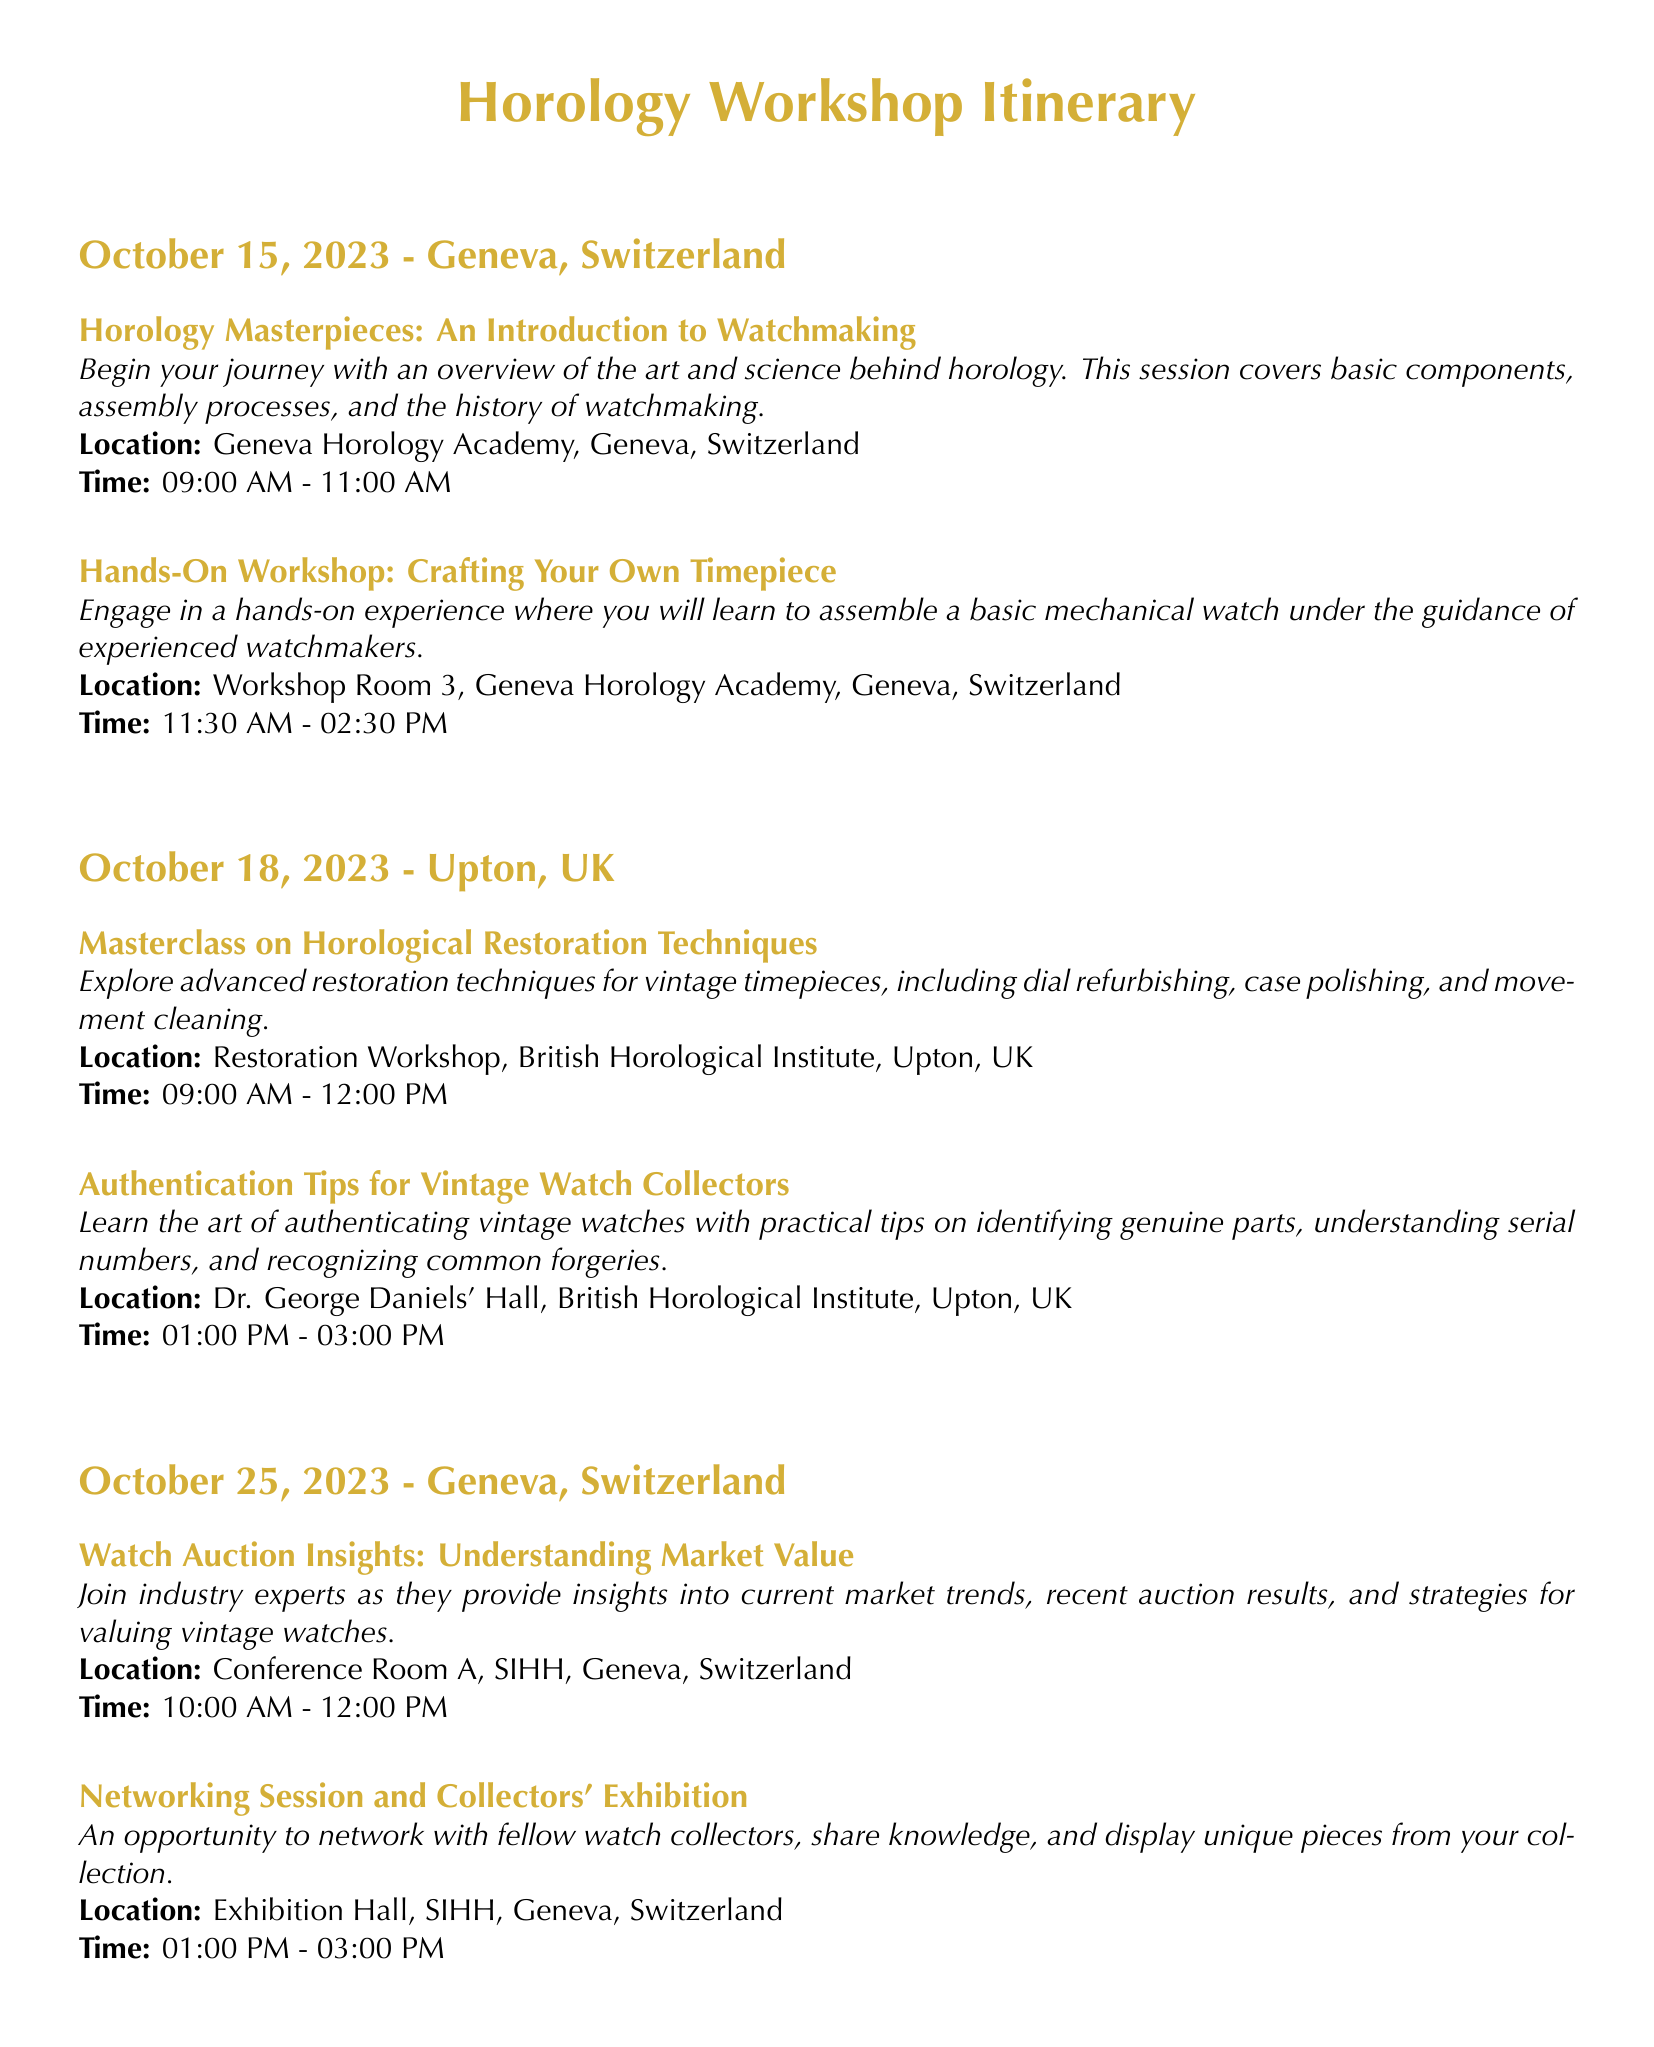What is the first workshop on the itinerary? The first workshop listed is "Horology Masterpieces: An Introduction to Watchmaking".
Answer: Horology Masterpieces: An Introduction to Watchmaking What is the location of the "Hands-On Workshop: Crafting Your Own Timepiece"? The workshop will take place in Workshop Room 3, Geneva Horology Academy, Geneva, Switzerland.
Answer: Workshop Room 3, Geneva Horology Academy, Geneva, Switzerland How long does the "Masterclass on Horological Restoration Techniques" last? The masterclass is scheduled from 09:00 AM to 12:00 PM, making it a 3-hour session.
Answer: 3 hours What date is the authentication tips workshop scheduled? The workshop is scheduled on October 18, 2023.
Answer: October 18, 2023 What is the time for the networking session on October 25, 2023? The networking session starts at 01:00 PM and ends at 03:00 PM.
Answer: 01:00 PM - 03:00 PM What is the total duration of events on October 15, 2023? The events consist of two workshops lasting 4 hours in total.
Answer: 4 hours What is the primary focus of the "Authentication Tips for Vintage Watch Collectors"? The focus is on authenticating vintage watches.
Answer: Authenticating vintage watches Who provides insights in the "Watch Auction Insights" workshop? Industry experts provide the insights during this workshop.
Answer: Industry experts What kind of event is held after the watch auction workshop? A networking session and collectors' exhibition follows.
Answer: Networking session and collectors' exhibition 